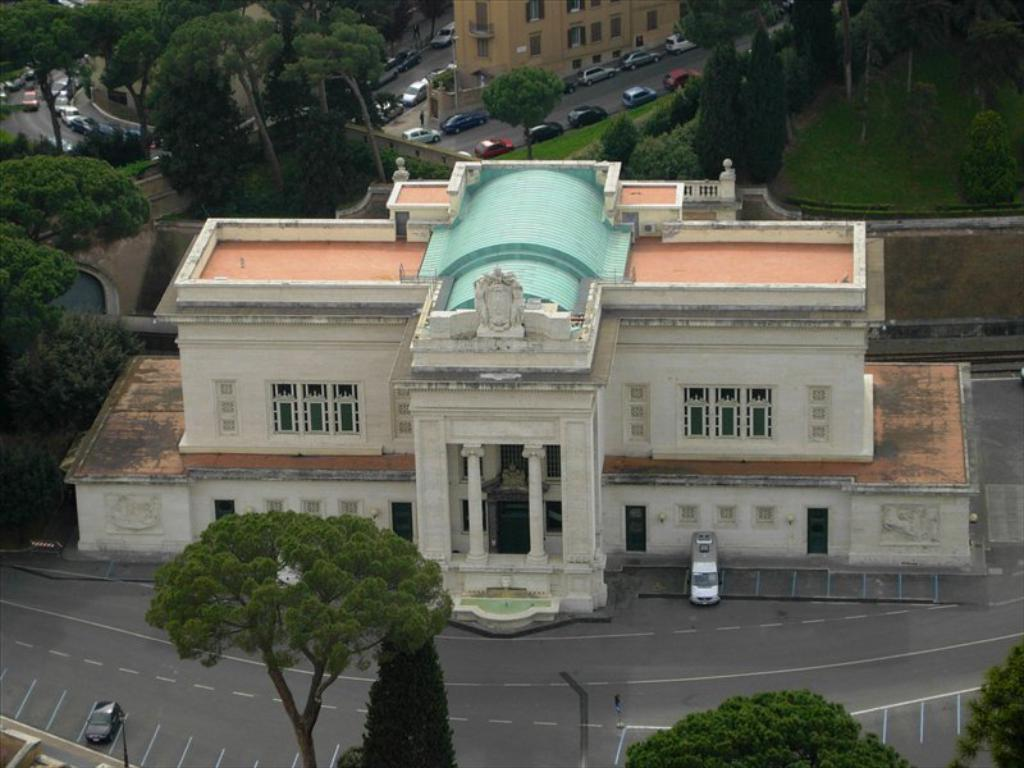What type of structures can be seen in the image? There are buildings in the image. What is happening on the road in the image? There are vehicles on the road in the image. What objects are present in the image that are used for supporting or holding things? There are poles in the image. What type of vegetation is visible in the image? There are trees in the image. What type of ground cover can be seen in the image? There is grass visible in the image. Can you tell me how many kittens are sitting on the cherries in the image? There are no kittens or cherries present in the image; it features buildings, vehicles, poles, trees, and grass. 